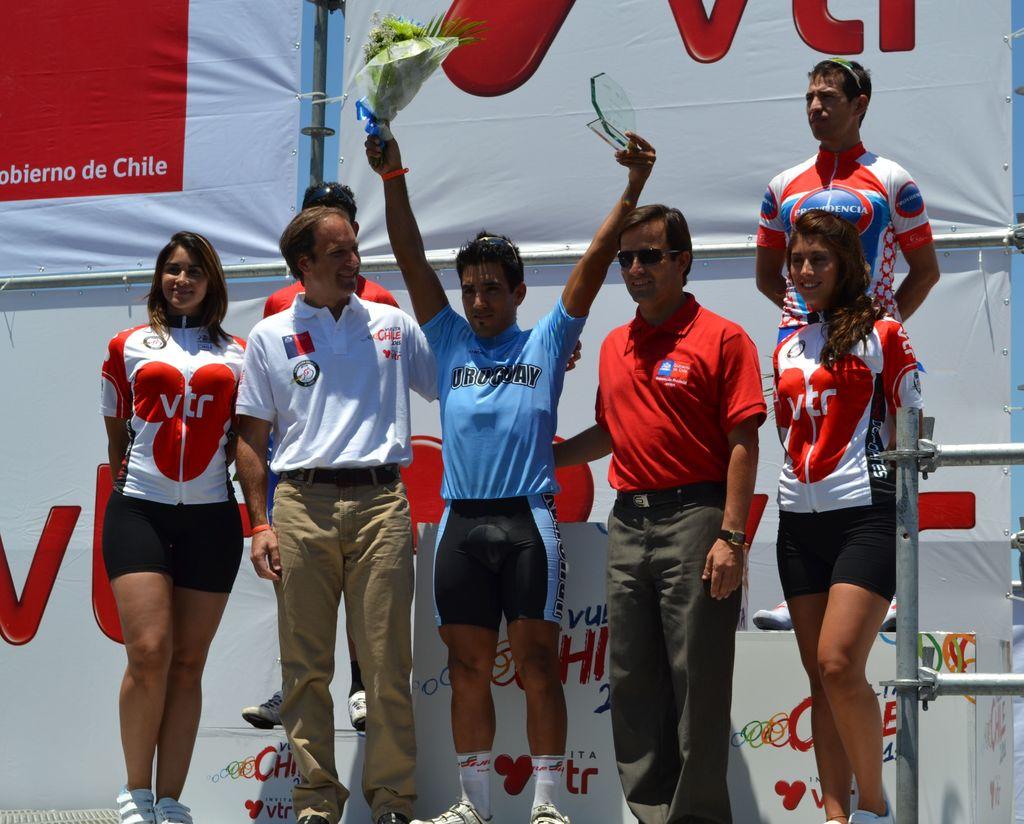What country is listed on the blue shirt?
Provide a succinct answer. Uruguay. 